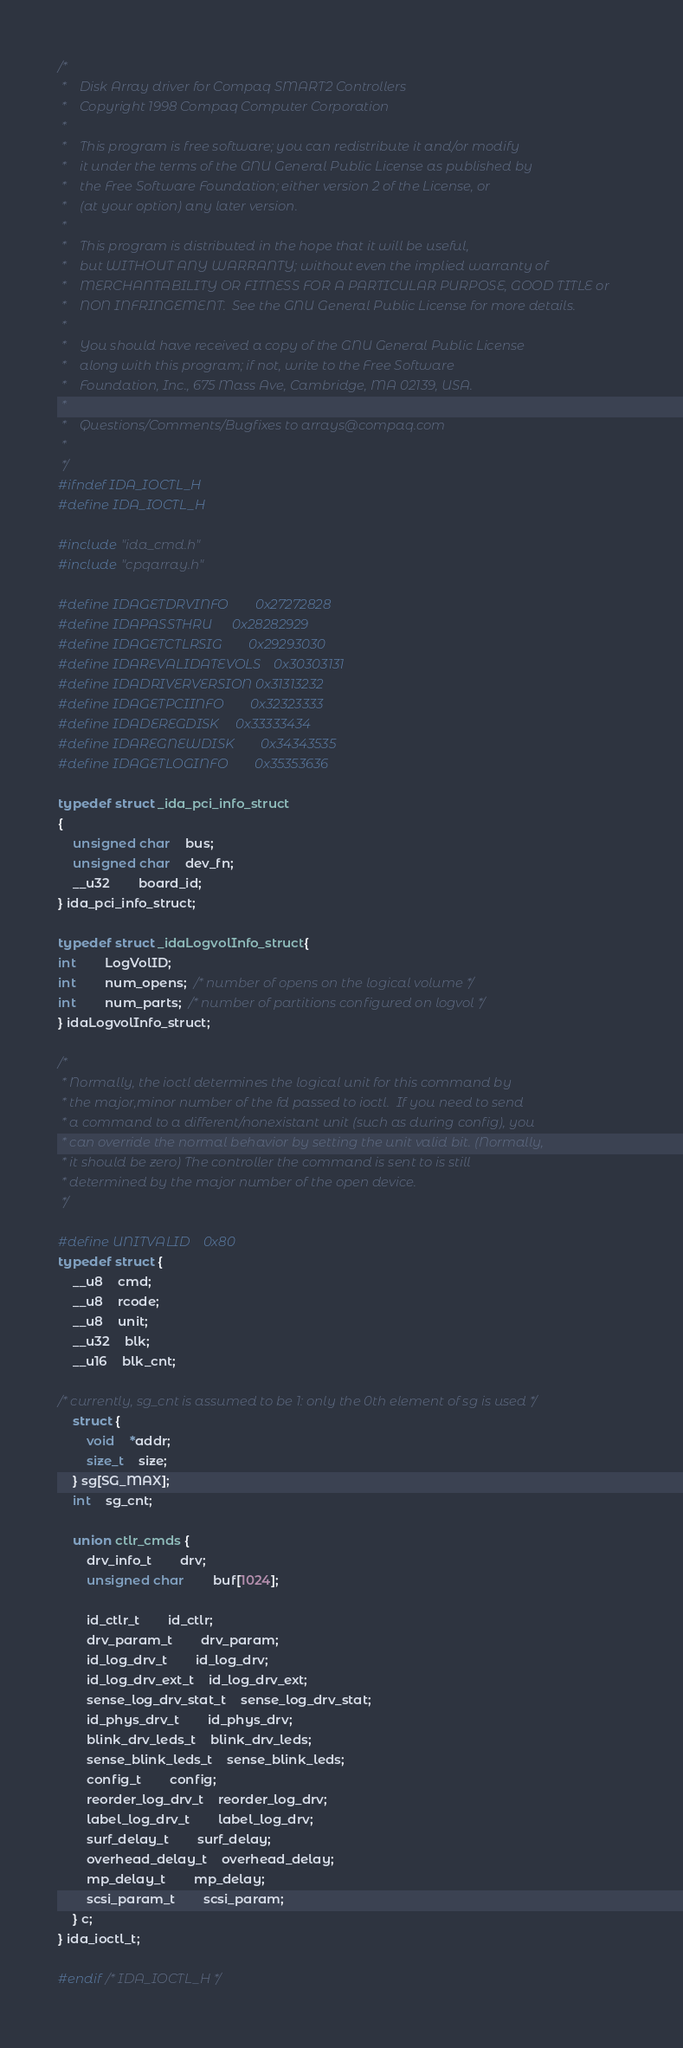<code> <loc_0><loc_0><loc_500><loc_500><_C_>/*
 *    Disk Array driver for Compaq SMART2 Controllers
 *    Copyright 1998 Compaq Computer Corporation
 *
 *    This program is free software; you can redistribute it and/or modify
 *    it under the terms of the GNU General Public License as published by
 *    the Free Software Foundation; either version 2 of the License, or
 *    (at your option) any later version.
 *
 *    This program is distributed in the hope that it will be useful,
 *    but WITHOUT ANY WARRANTY; without even the implied warranty of
 *    MERCHANTABILITY OR FITNESS FOR A PARTICULAR PURPOSE, GOOD TITLE or
 *    NON INFRINGEMENT.  See the GNU General Public License for more details.
 *
 *    You should have received a copy of the GNU General Public License
 *    along with this program; if not, write to the Free Software
 *    Foundation, Inc., 675 Mass Ave, Cambridge, MA 02139, USA.
 *
 *    Questions/Comments/Bugfixes to arrays@compaq.com
 *
 */
#ifndef IDA_IOCTL_H
#define IDA_IOCTL_H

#include "ida_cmd.h"
#include "cpqarray.h"

#define IDAGETDRVINFO		0x27272828
#define IDAPASSTHRU		0x28282929
#define IDAGETCTLRSIG		0x29293030
#define IDAREVALIDATEVOLS	0x30303131
#define IDADRIVERVERSION	0x31313232
#define IDAGETPCIINFO		0x32323333
#define IDADEREGDISK		0x33333434
#define IDAREGNEWDISK		0x34343535
#define IDAGETLOGINFO		0x35353636

typedef struct _ida_pci_info_struct
{
	unsigned char 	bus;
	unsigned char 	dev_fn;
	__u32 		board_id;
} ida_pci_info_struct;

typedef struct _idaLogvolInfo_struct{
int		LogVolID;
int		num_opens;  /* number of opens on the logical volume */
int		num_parts;  /* number of partitions configured on logvol */
} idaLogvolInfo_struct;

/*
 * Normally, the ioctl determines the logical unit for this command by
 * the major,minor number of the fd passed to ioctl.  If you need to send
 * a command to a different/nonexistant unit (such as during config), you
 * can override the normal behavior by setting the unit valid bit. (Normally,
 * it should be zero) The controller the command is sent to is still
 * determined by the major number of the open device.
 */

#define UNITVALID	0x80
typedef struct {
	__u8	cmd;
	__u8	rcode;
	__u8	unit;
	__u32	blk;
	__u16	blk_cnt;

/* currently, sg_cnt is assumed to be 1: only the 0th element of sg is used */
	struct {
		void	*addr;
		size_t	size;
	} sg[SG_MAX];
	int	sg_cnt;

	union ctlr_cmds {
		drv_info_t		drv;
		unsigned char		buf[1024];

		id_ctlr_t		id_ctlr;
		drv_param_t		drv_param;
		id_log_drv_t		id_log_drv;
		id_log_drv_ext_t	id_log_drv_ext;
		sense_log_drv_stat_t	sense_log_drv_stat;
		id_phys_drv_t		id_phys_drv;
		blink_drv_leds_t	blink_drv_leds;
		sense_blink_leds_t	sense_blink_leds;
		config_t		config;
		reorder_log_drv_t	reorder_log_drv;
		label_log_drv_t		label_log_drv;
		surf_delay_t		surf_delay;
		overhead_delay_t	overhead_delay;
		mp_delay_t		mp_delay;
		scsi_param_t		scsi_param;
	} c;
} ida_ioctl_t;

#endif /* IDA_IOCTL_H */
</code> 